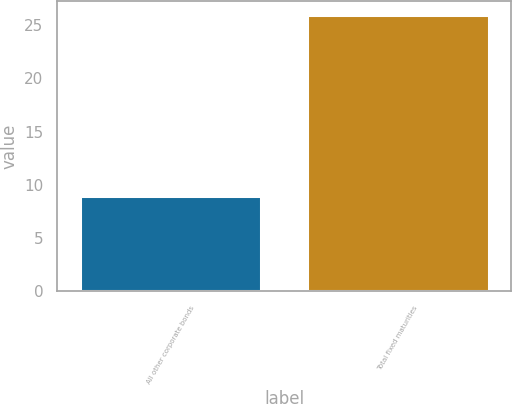Convert chart to OTSL. <chart><loc_0><loc_0><loc_500><loc_500><bar_chart><fcel>All other corporate bonds<fcel>Total fixed maturities<nl><fcel>9<fcel>26<nl></chart> 